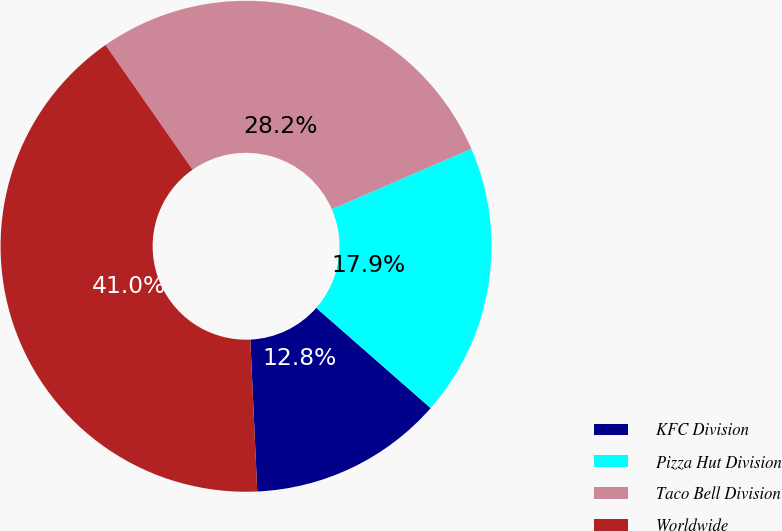<chart> <loc_0><loc_0><loc_500><loc_500><pie_chart><fcel>KFC Division<fcel>Pizza Hut Division<fcel>Taco Bell Division<fcel>Worldwide<nl><fcel>12.82%<fcel>17.95%<fcel>28.21%<fcel>41.03%<nl></chart> 